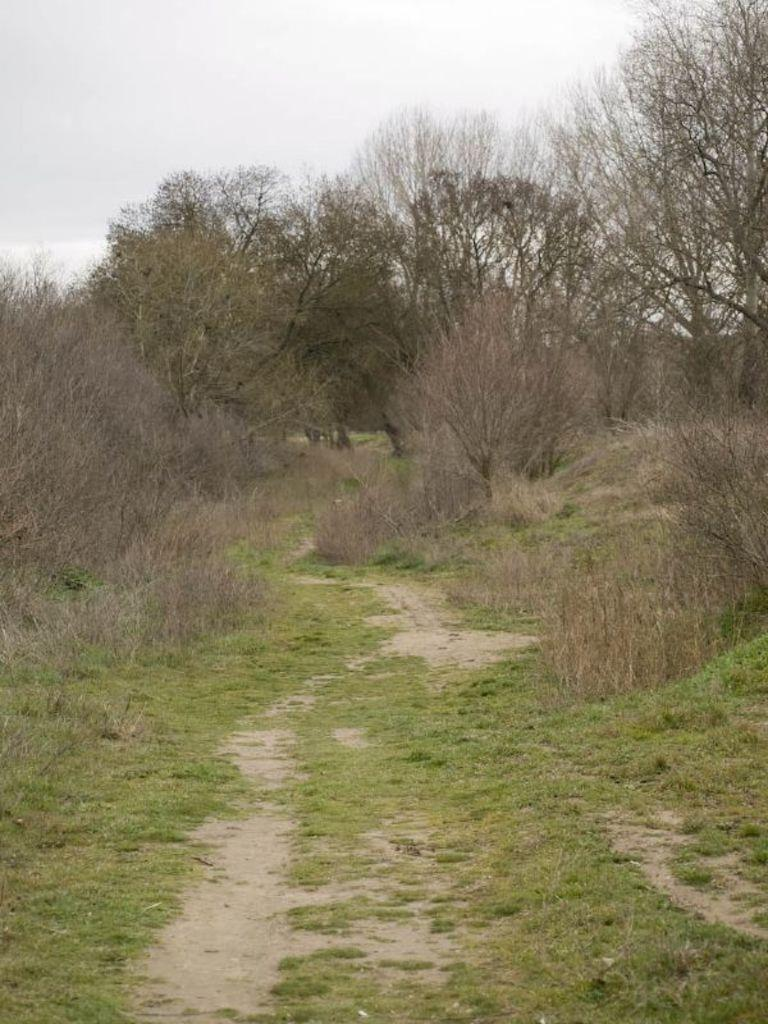What type of vegetation is visible at the front of the image? There is grass in front of the image. What can be seen in the middle of the image? There are plants and trees in the middle of the image. What is visible in the background of the image? The sky is visible in the background of the image. How many boats can be seen sailing in the sky in the image? There are no boats visible in the image, and the sky is not occupied by any boats. 